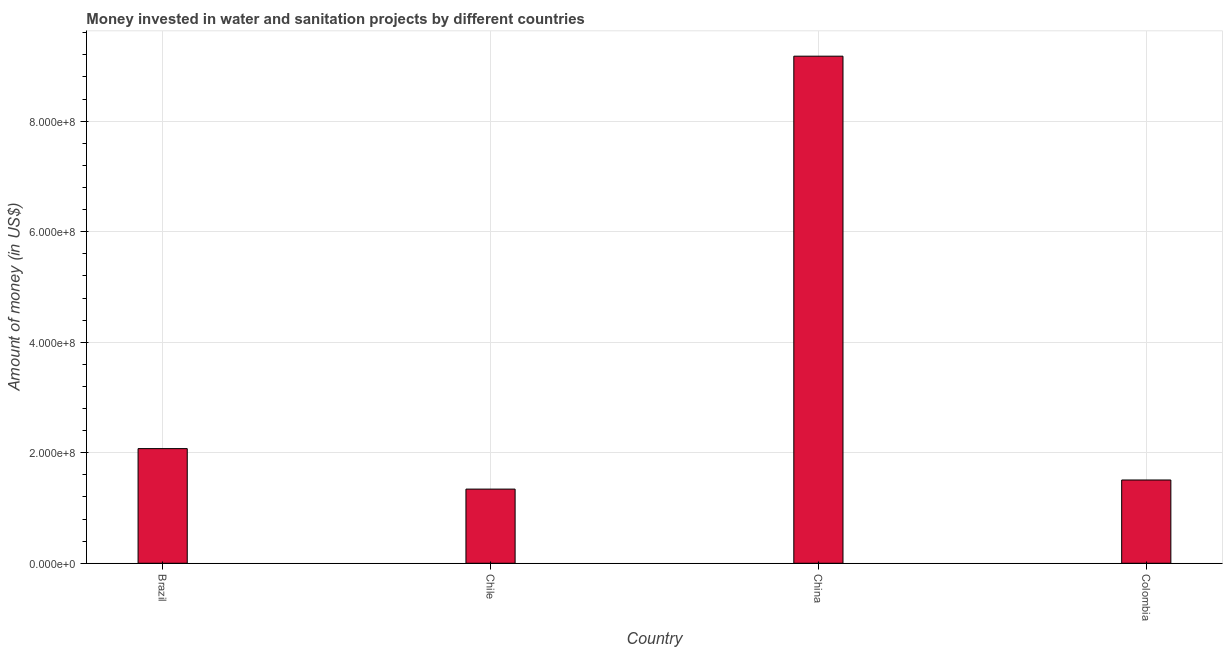Does the graph contain any zero values?
Ensure brevity in your answer.  No. Does the graph contain grids?
Ensure brevity in your answer.  Yes. What is the title of the graph?
Make the answer very short. Money invested in water and sanitation projects by different countries. What is the label or title of the X-axis?
Keep it short and to the point. Country. What is the label or title of the Y-axis?
Your response must be concise. Amount of money (in US$). What is the investment in Colombia?
Ensure brevity in your answer.  1.51e+08. Across all countries, what is the maximum investment?
Offer a terse response. 9.18e+08. Across all countries, what is the minimum investment?
Keep it short and to the point. 1.34e+08. In which country was the investment minimum?
Make the answer very short. Chile. What is the sum of the investment?
Ensure brevity in your answer.  1.41e+09. What is the difference between the investment in Brazil and Colombia?
Give a very brief answer. 5.68e+07. What is the average investment per country?
Provide a succinct answer. 3.53e+08. What is the median investment?
Keep it short and to the point. 1.79e+08. In how many countries, is the investment greater than 440000000 US$?
Provide a succinct answer. 1. What is the ratio of the investment in Chile to that in China?
Your response must be concise. 0.15. Is the difference between the investment in Brazil and Chile greater than the difference between any two countries?
Ensure brevity in your answer.  No. What is the difference between the highest and the second highest investment?
Give a very brief answer. 7.10e+08. Is the sum of the investment in Brazil and Colombia greater than the maximum investment across all countries?
Your answer should be very brief. No. What is the difference between the highest and the lowest investment?
Your answer should be compact. 7.83e+08. Are the values on the major ticks of Y-axis written in scientific E-notation?
Provide a succinct answer. Yes. What is the Amount of money (in US$) in Brazil?
Offer a terse response. 2.07e+08. What is the Amount of money (in US$) in Chile?
Offer a very short reply. 1.34e+08. What is the Amount of money (in US$) of China?
Your answer should be compact. 9.18e+08. What is the Amount of money (in US$) in Colombia?
Make the answer very short. 1.51e+08. What is the difference between the Amount of money (in US$) in Brazil and Chile?
Keep it short and to the point. 7.33e+07. What is the difference between the Amount of money (in US$) in Brazil and China?
Offer a very short reply. -7.10e+08. What is the difference between the Amount of money (in US$) in Brazil and Colombia?
Provide a short and direct response. 5.68e+07. What is the difference between the Amount of money (in US$) in Chile and China?
Offer a very short reply. -7.83e+08. What is the difference between the Amount of money (in US$) in Chile and Colombia?
Make the answer very short. -1.65e+07. What is the difference between the Amount of money (in US$) in China and Colombia?
Offer a very short reply. 7.67e+08. What is the ratio of the Amount of money (in US$) in Brazil to that in Chile?
Provide a succinct answer. 1.55. What is the ratio of the Amount of money (in US$) in Brazil to that in China?
Give a very brief answer. 0.23. What is the ratio of the Amount of money (in US$) in Brazil to that in Colombia?
Keep it short and to the point. 1.38. What is the ratio of the Amount of money (in US$) in Chile to that in China?
Offer a very short reply. 0.15. What is the ratio of the Amount of money (in US$) in Chile to that in Colombia?
Offer a terse response. 0.89. What is the ratio of the Amount of money (in US$) in China to that in Colombia?
Offer a terse response. 6.09. 